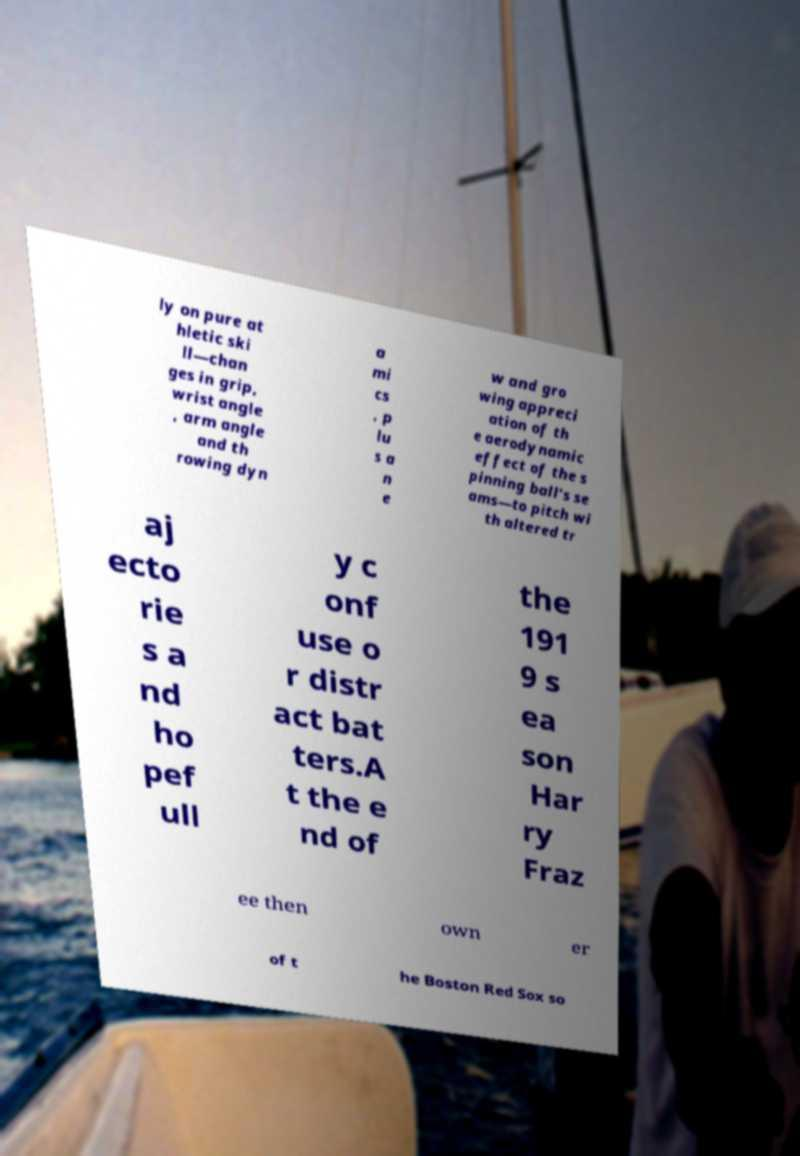For documentation purposes, I need the text within this image transcribed. Could you provide that? ly on pure at hletic ski ll—chan ges in grip, wrist angle , arm angle and th rowing dyn a mi cs , p lu s a n e w and gro wing appreci ation of th e aerodynamic effect of the s pinning ball's se ams—to pitch wi th altered tr aj ecto rie s a nd ho pef ull y c onf use o r distr act bat ters.A t the e nd of the 191 9 s ea son Har ry Fraz ee then own er of t he Boston Red Sox so 